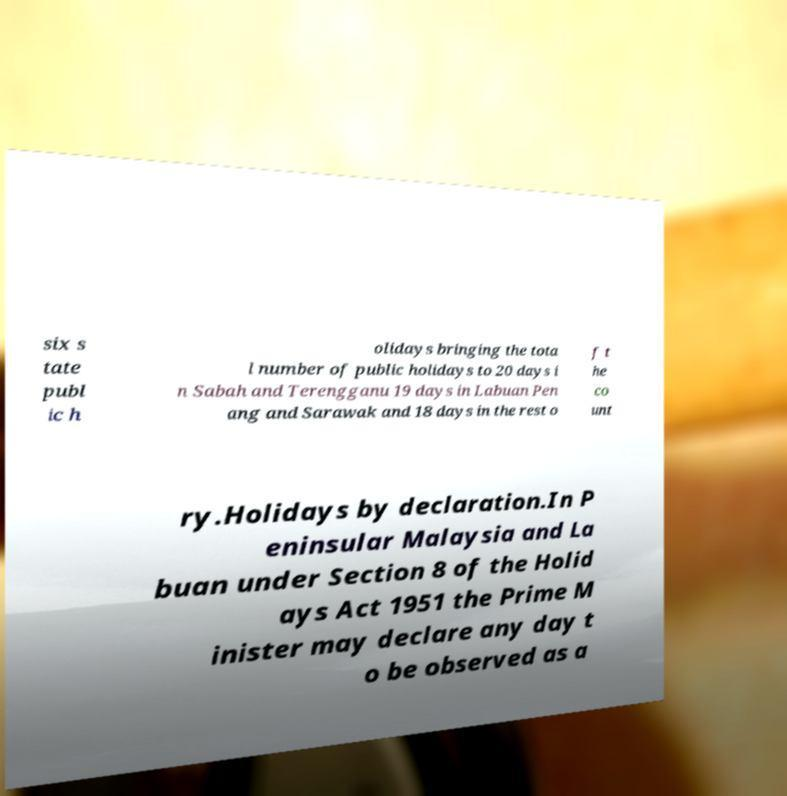Please identify and transcribe the text found in this image. six s tate publ ic h olidays bringing the tota l number of public holidays to 20 days i n Sabah and Terengganu 19 days in Labuan Pen ang and Sarawak and 18 days in the rest o f t he co unt ry.Holidays by declaration.In P eninsular Malaysia and La buan under Section 8 of the Holid ays Act 1951 the Prime M inister may declare any day t o be observed as a 